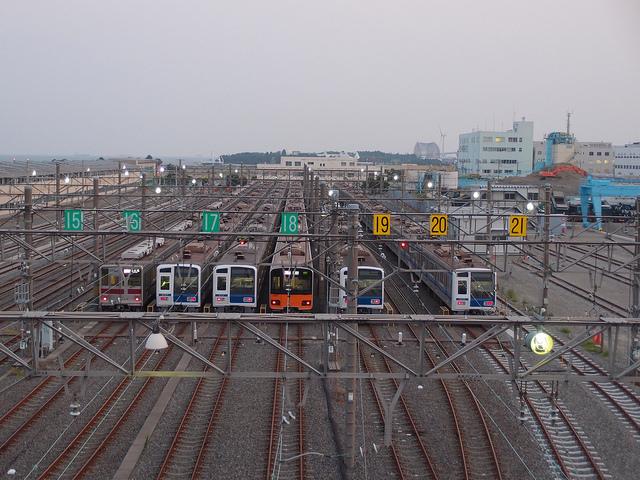Are the trains moving?
Quick response, please. No. What color is number nineteen?
Keep it brief. Yellow. What is likely to the left of this picture?
Give a very brief answer. Train station. 